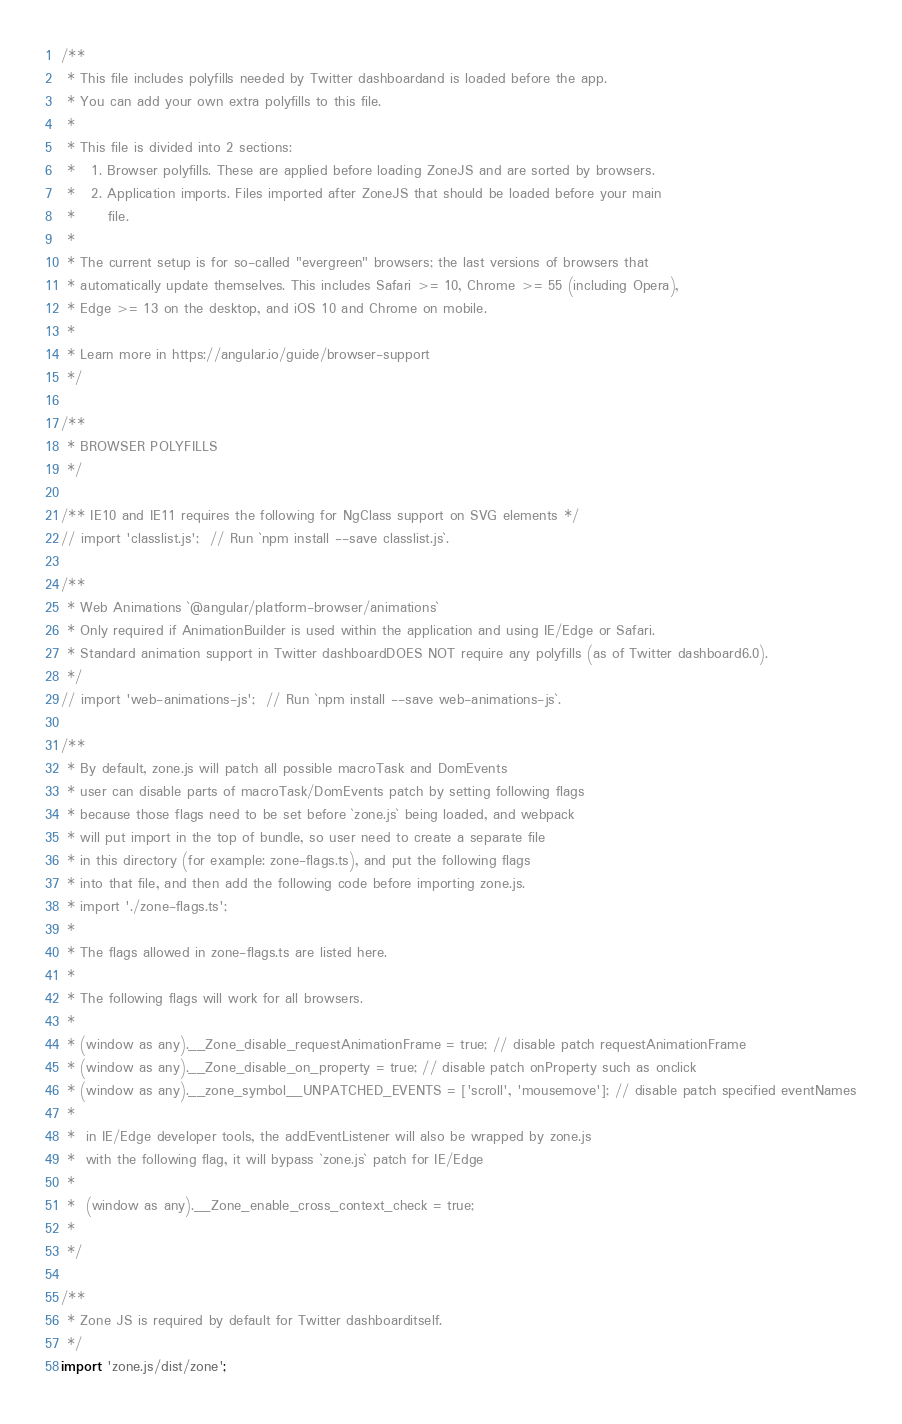<code> <loc_0><loc_0><loc_500><loc_500><_TypeScript_>/**
 * This file includes polyfills needed by Twitter dashboardand is loaded before the app.
 * You can add your own extra polyfills to this file.
 *
 * This file is divided into 2 sections:
 *   1. Browser polyfills. These are applied before loading ZoneJS and are sorted by browsers.
 *   2. Application imports. Files imported after ZoneJS that should be loaded before your main
 *      file.
 *
 * The current setup is for so-called "evergreen" browsers; the last versions of browsers that
 * automatically update themselves. This includes Safari >= 10, Chrome >= 55 (including Opera),
 * Edge >= 13 on the desktop, and iOS 10 and Chrome on mobile.
 *
 * Learn more in https://angular.io/guide/browser-support
 */

/**
 * BROWSER POLYFILLS
 */

/** IE10 and IE11 requires the following for NgClass support on SVG elements */
// import 'classlist.js';  // Run `npm install --save classlist.js`.

/**
 * Web Animations `@angular/platform-browser/animations`
 * Only required if AnimationBuilder is used within the application and using IE/Edge or Safari.
 * Standard animation support in Twitter dashboardDOES NOT require any polyfills (as of Twitter dashboard6.0).
 */
// import 'web-animations-js';  // Run `npm install --save web-animations-js`.

/**
 * By default, zone.js will patch all possible macroTask and DomEvents
 * user can disable parts of macroTask/DomEvents patch by setting following flags
 * because those flags need to be set before `zone.js` being loaded, and webpack
 * will put import in the top of bundle, so user need to create a separate file
 * in this directory (for example: zone-flags.ts), and put the following flags
 * into that file, and then add the following code before importing zone.js.
 * import './zone-flags.ts';
 *
 * The flags allowed in zone-flags.ts are listed here.
 *
 * The following flags will work for all browsers.
 *
 * (window as any).__Zone_disable_requestAnimationFrame = true; // disable patch requestAnimationFrame
 * (window as any).__Zone_disable_on_property = true; // disable patch onProperty such as onclick
 * (window as any).__zone_symbol__UNPATCHED_EVENTS = ['scroll', 'mousemove']; // disable patch specified eventNames
 *
 *  in IE/Edge developer tools, the addEventListener will also be wrapped by zone.js
 *  with the following flag, it will bypass `zone.js` patch for IE/Edge
 *
 *  (window as any).__Zone_enable_cross_context_check = true;
 *
 */

/**
 * Zone JS is required by default for Twitter dashboarditself.
 */
import 'zone.js/dist/zone';
</code> 